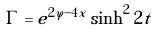<formula> <loc_0><loc_0><loc_500><loc_500>\Gamma = e ^ { 2 \varphi - 4 x } \sinh ^ { 2 } 2 t</formula> 